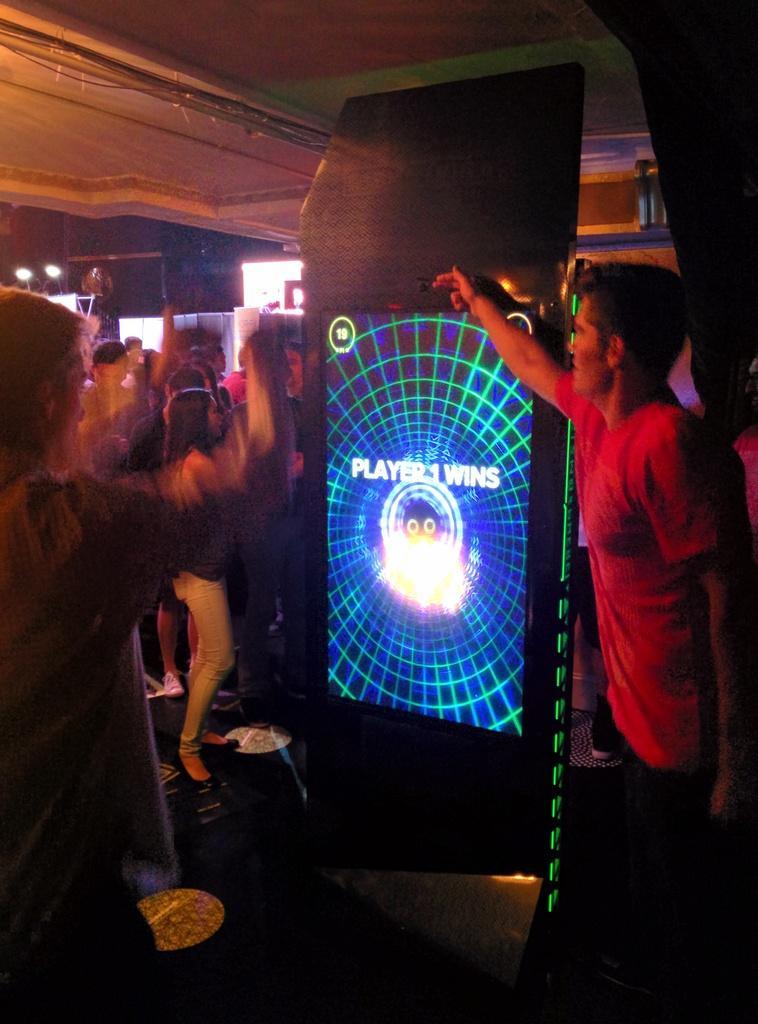Describe this image in one or two sentences. The picture is taken in a bar or a party. In the foreground there are people and an electronic gadget. In the center of the picture there are people dancing. In the background there are lights and other objects. 